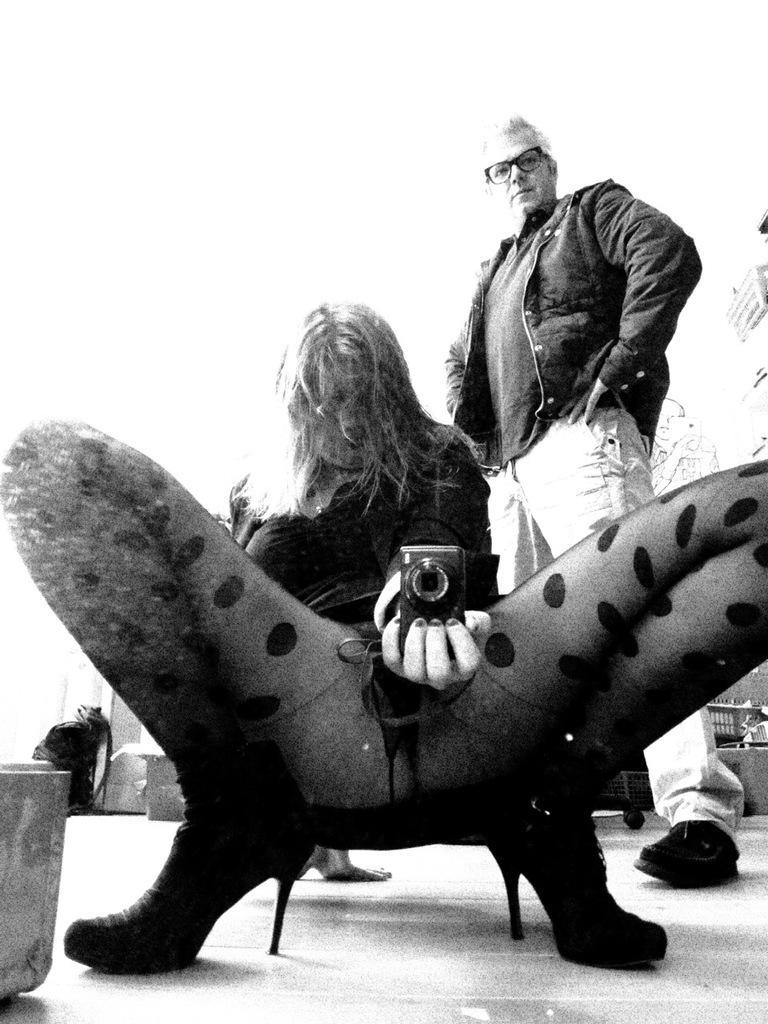How would you summarize this image in a sentence or two? In this image in the foreground there is one woman who is holding a camera, and in the background there is another man standing and there are some objects. At the bottom there is floor. 